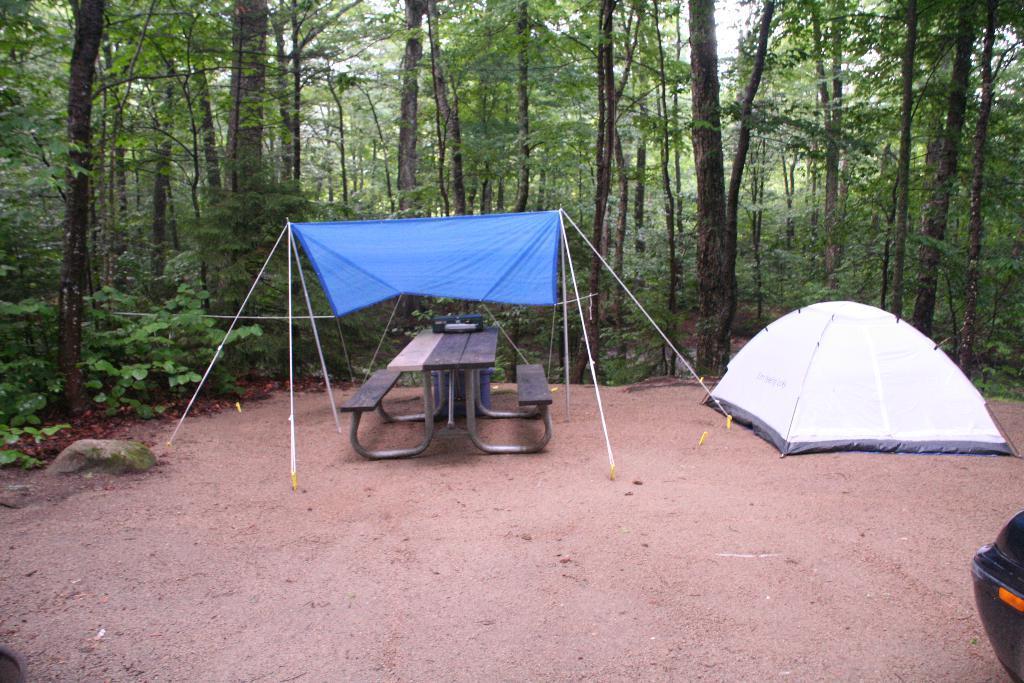In one or two sentences, can you explain what this image depicts? In the foreground of the picture we can see tents, bench, soil and other objects. In the background we can see plants, trees and sky. 